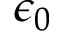<formula> <loc_0><loc_0><loc_500><loc_500>\epsilon _ { 0 }</formula> 